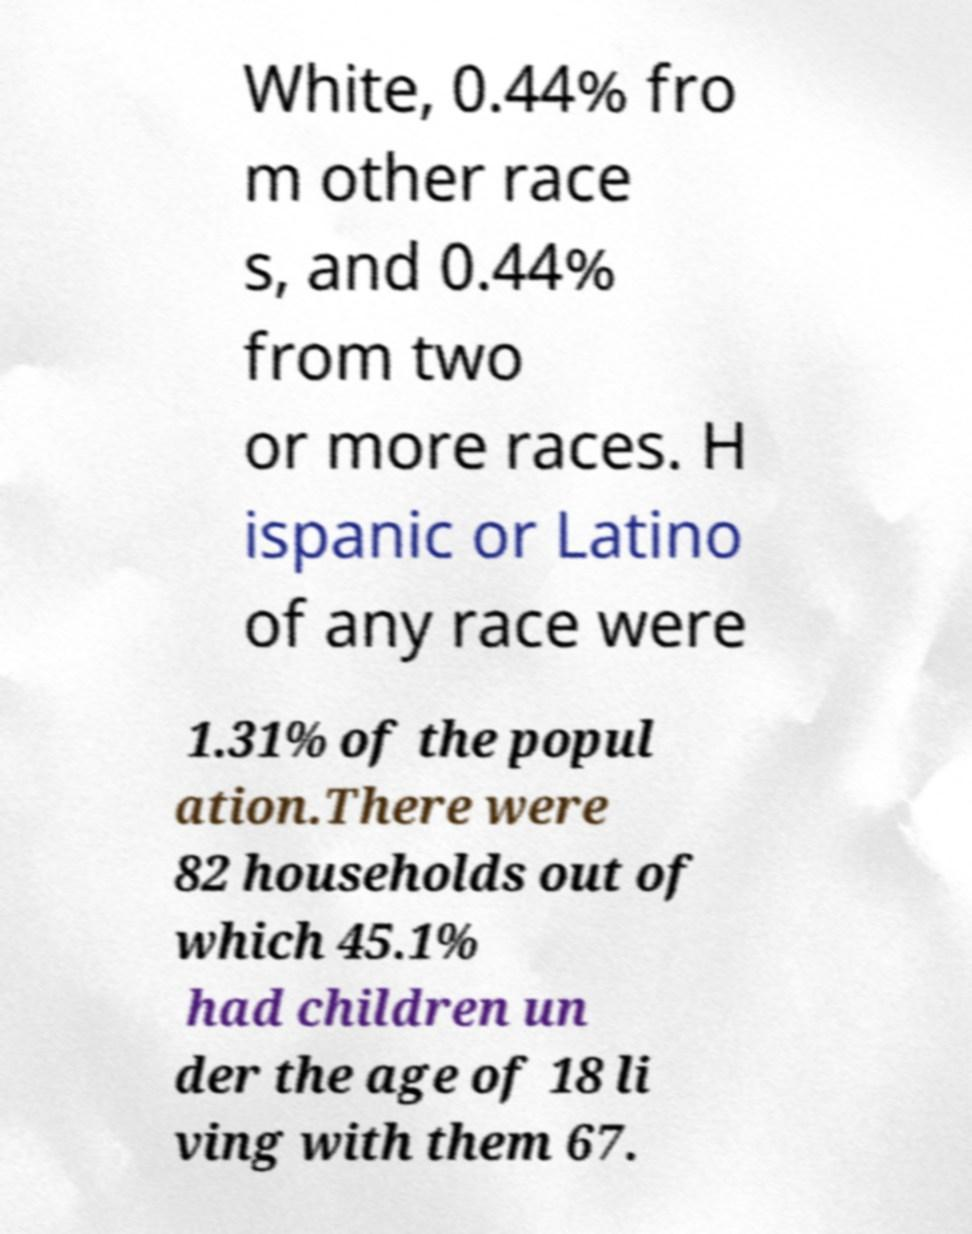Please identify and transcribe the text found in this image. White, 0.44% fro m other race s, and 0.44% from two or more races. H ispanic or Latino of any race were 1.31% of the popul ation.There were 82 households out of which 45.1% had children un der the age of 18 li ving with them 67. 